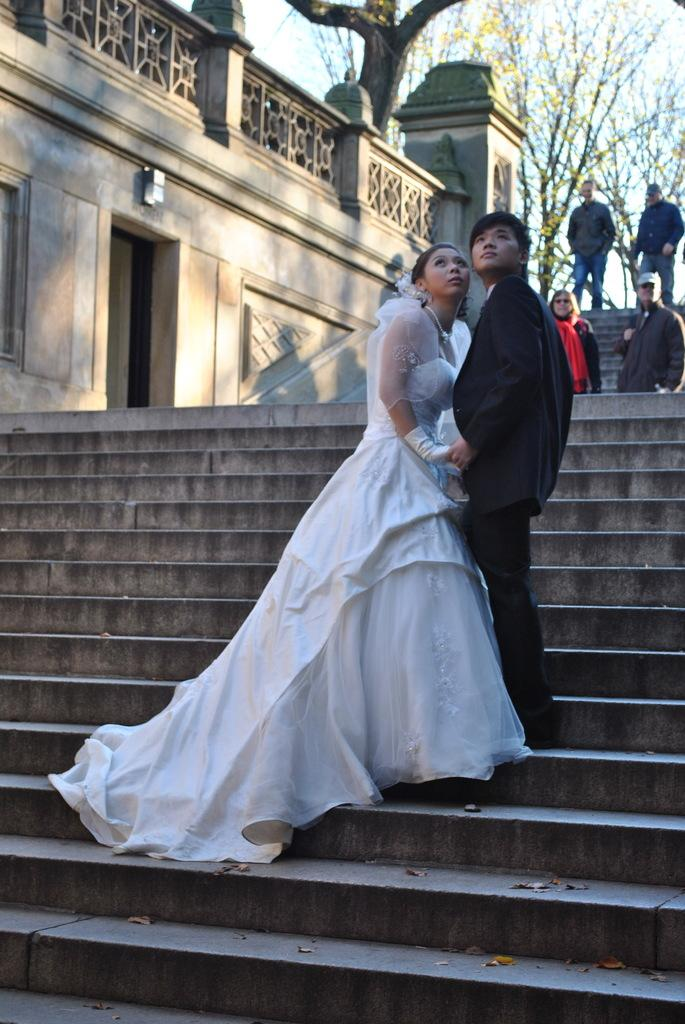Who is present in the image? There is a couple in the image. Where are the couple located? The couple is standing on the stairs. What are the couple doing in the image? The couple is staring at something. What else can be seen happening on the stairs in the image? There are people walking on the stairs in the image. What can be seen in the background of the image? There are trees in the background of the image. What type of lock is being used to secure the war in the image? There is no war or lock present in the image. 